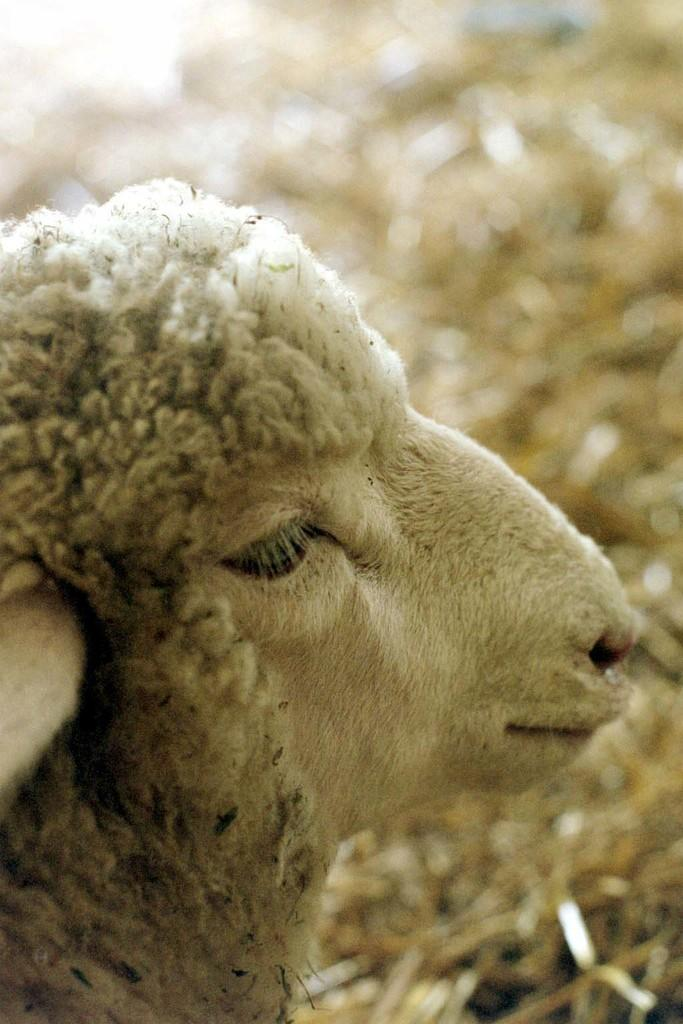What type of animal is in the image? The specific type of animal cannot be determined from the provided facts. Can you describe the background of the image? The background of the image is blurry. What color is the cover on the animal's head in the image? There is no cover on the animal's head in the image, as the type of animal is not specified. How many rings can be seen on the animal's tail in the image? There is no information about rings or tails in the image, as the type of animal is not specified. 